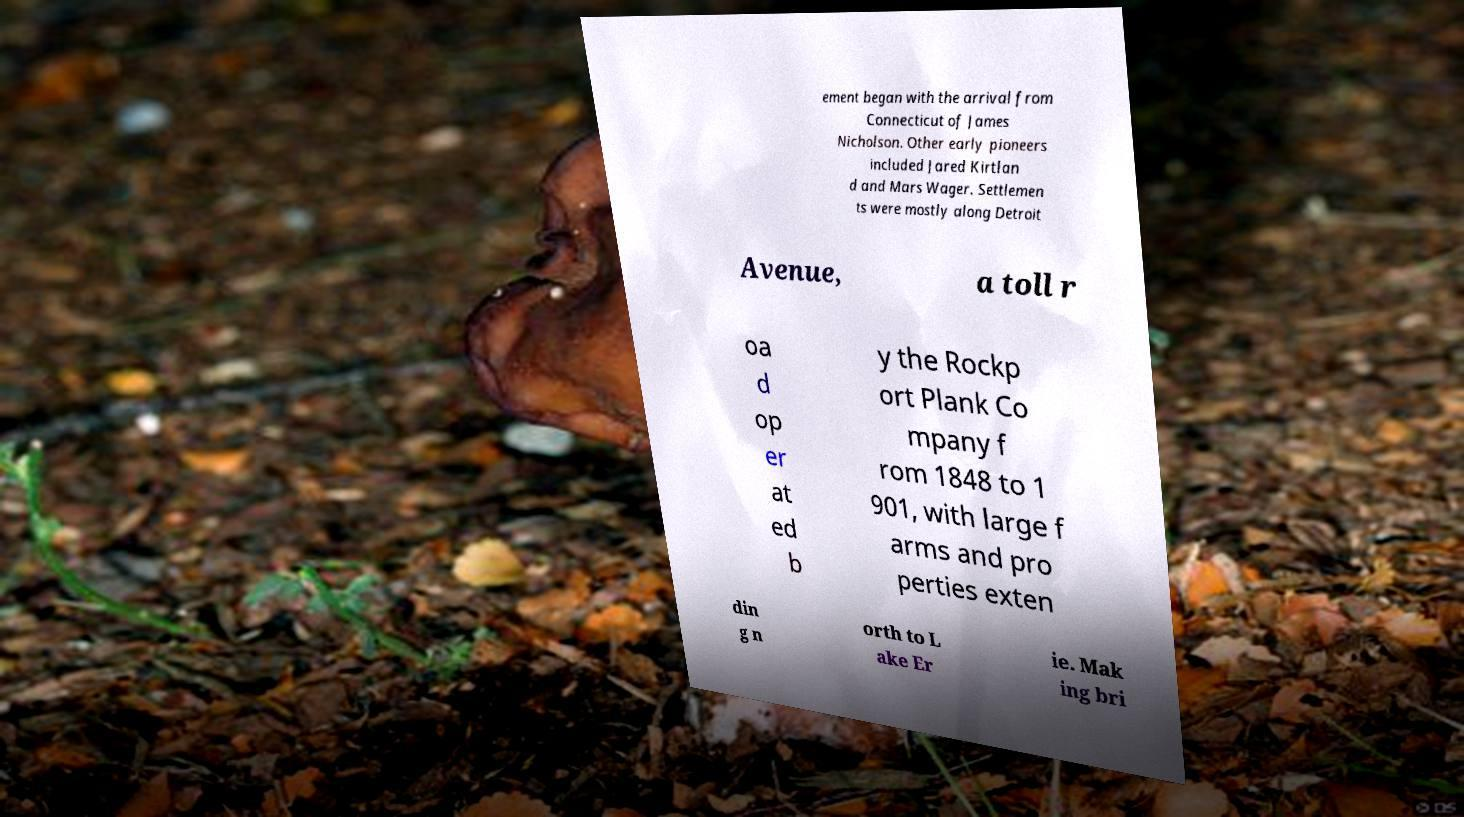Could you extract and type out the text from this image? ement began with the arrival from Connecticut of James Nicholson. Other early pioneers included Jared Kirtlan d and Mars Wager. Settlemen ts were mostly along Detroit Avenue, a toll r oa d op er at ed b y the Rockp ort Plank Co mpany f rom 1848 to 1 901, with large f arms and pro perties exten din g n orth to L ake Er ie. Mak ing bri 